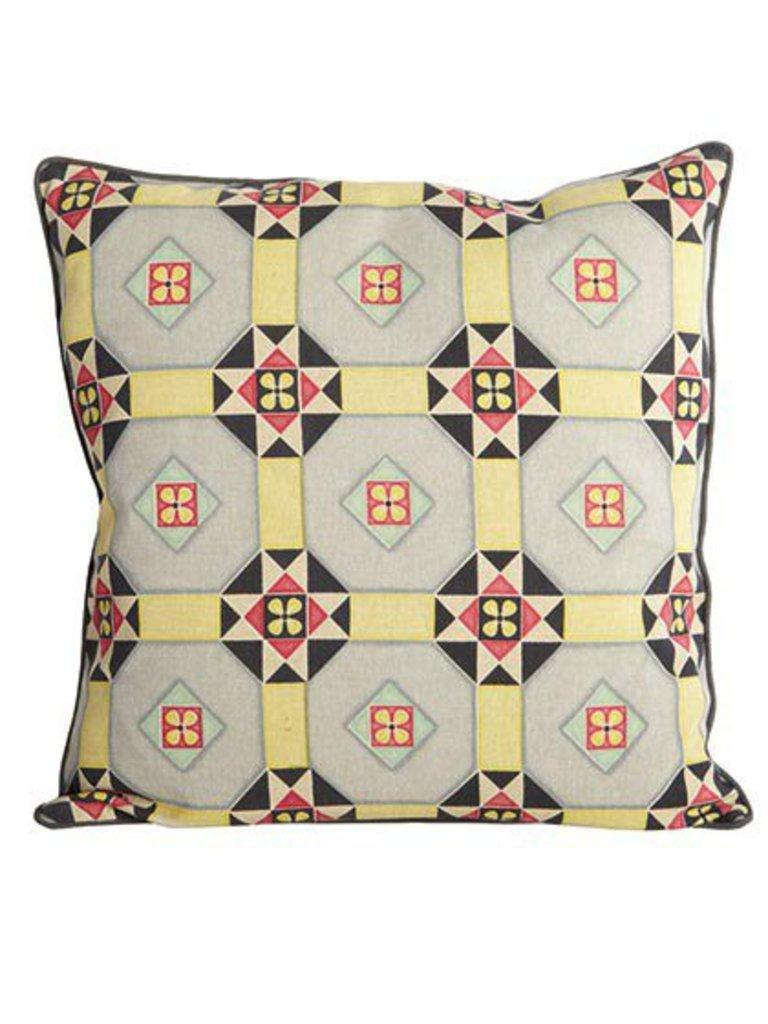What object can be seen in the image? There is a pillow in the image. What is unique about the pillow's appearance? The pillow has designs on it. What book is the pillow reading in the image? There is no book present in the image, and pillows do not have the ability to read. 